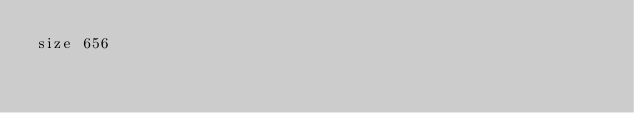Convert code to text. <code><loc_0><loc_0><loc_500><loc_500><_YAML_>size 656
</code> 